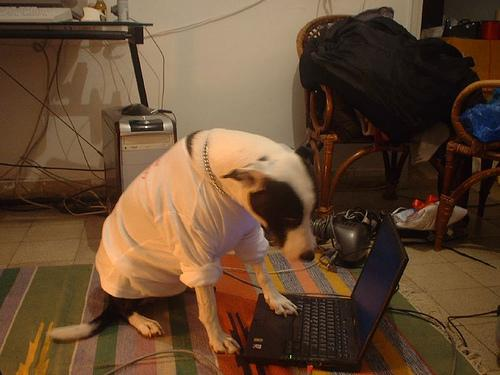What is the dog's paw resting on?

Choices:
A) apple
B) keyboard
C) bone
D) cat keyboard 